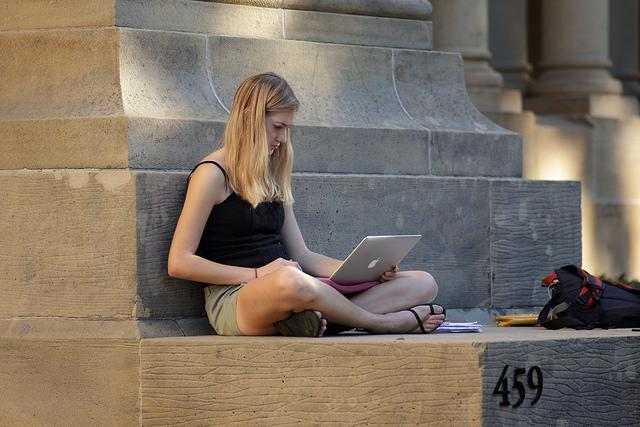How might this person easily look up the phone number for a taxi? internet search 